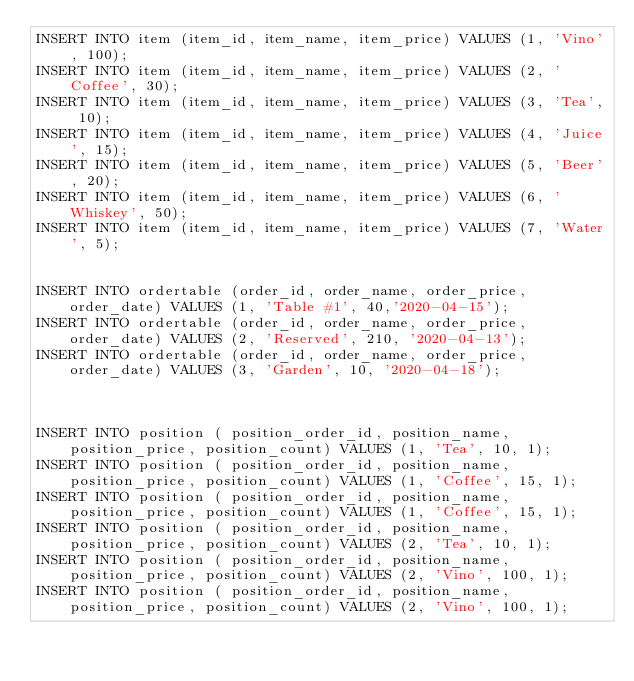<code> <loc_0><loc_0><loc_500><loc_500><_SQL_>INSERT INTO item (item_id, item_name, item_price) VALUES (1, 'Vino', 100);
INSERT INTO item (item_id, item_name, item_price) VALUES (2, 'Coffee', 30);
INSERT INTO item (item_id, item_name, item_price) VALUES (3, 'Tea', 10);
INSERT INTO item (item_id, item_name, item_price) VALUES (4, 'Juice', 15);
INSERT INTO item (item_id, item_name, item_price) VALUES (5, 'Beer', 20);
INSERT INTO item (item_id, item_name, item_price) VALUES (6, 'Whiskey', 50);
INSERT INTO item (item_id, item_name, item_price) VALUES (7, 'Water', 5);


INSERT INTO ordertable (order_id, order_name, order_price, order_date) VALUES (1, 'Table #1', 40,'2020-04-15');
INSERT INTO ordertable (order_id, order_name, order_price, order_date) VALUES (2, 'Reserved', 210, '2020-04-13');
INSERT INTO ordertable (order_id, order_name, order_price, order_date) VALUES (3, 'Garden', 10, '2020-04-18');



INSERT INTO position ( position_order_id, position_name, position_price, position_count) VALUES (1, 'Tea', 10, 1);
INSERT INTO position ( position_order_id, position_name, position_price, position_count) VALUES (1, 'Coffee', 15, 1);
INSERT INTO position ( position_order_id, position_name, position_price, position_count) VALUES (1, 'Coffee', 15, 1);
INSERT INTO position ( position_order_id, position_name, position_price, position_count) VALUES (2, 'Tea', 10, 1);
INSERT INTO position ( position_order_id, position_name, position_price, position_count) VALUES (2, 'Vino', 100, 1);
INSERT INTO position ( position_order_id, position_name, position_price, position_count) VALUES (2, 'Vino', 100, 1);</code> 